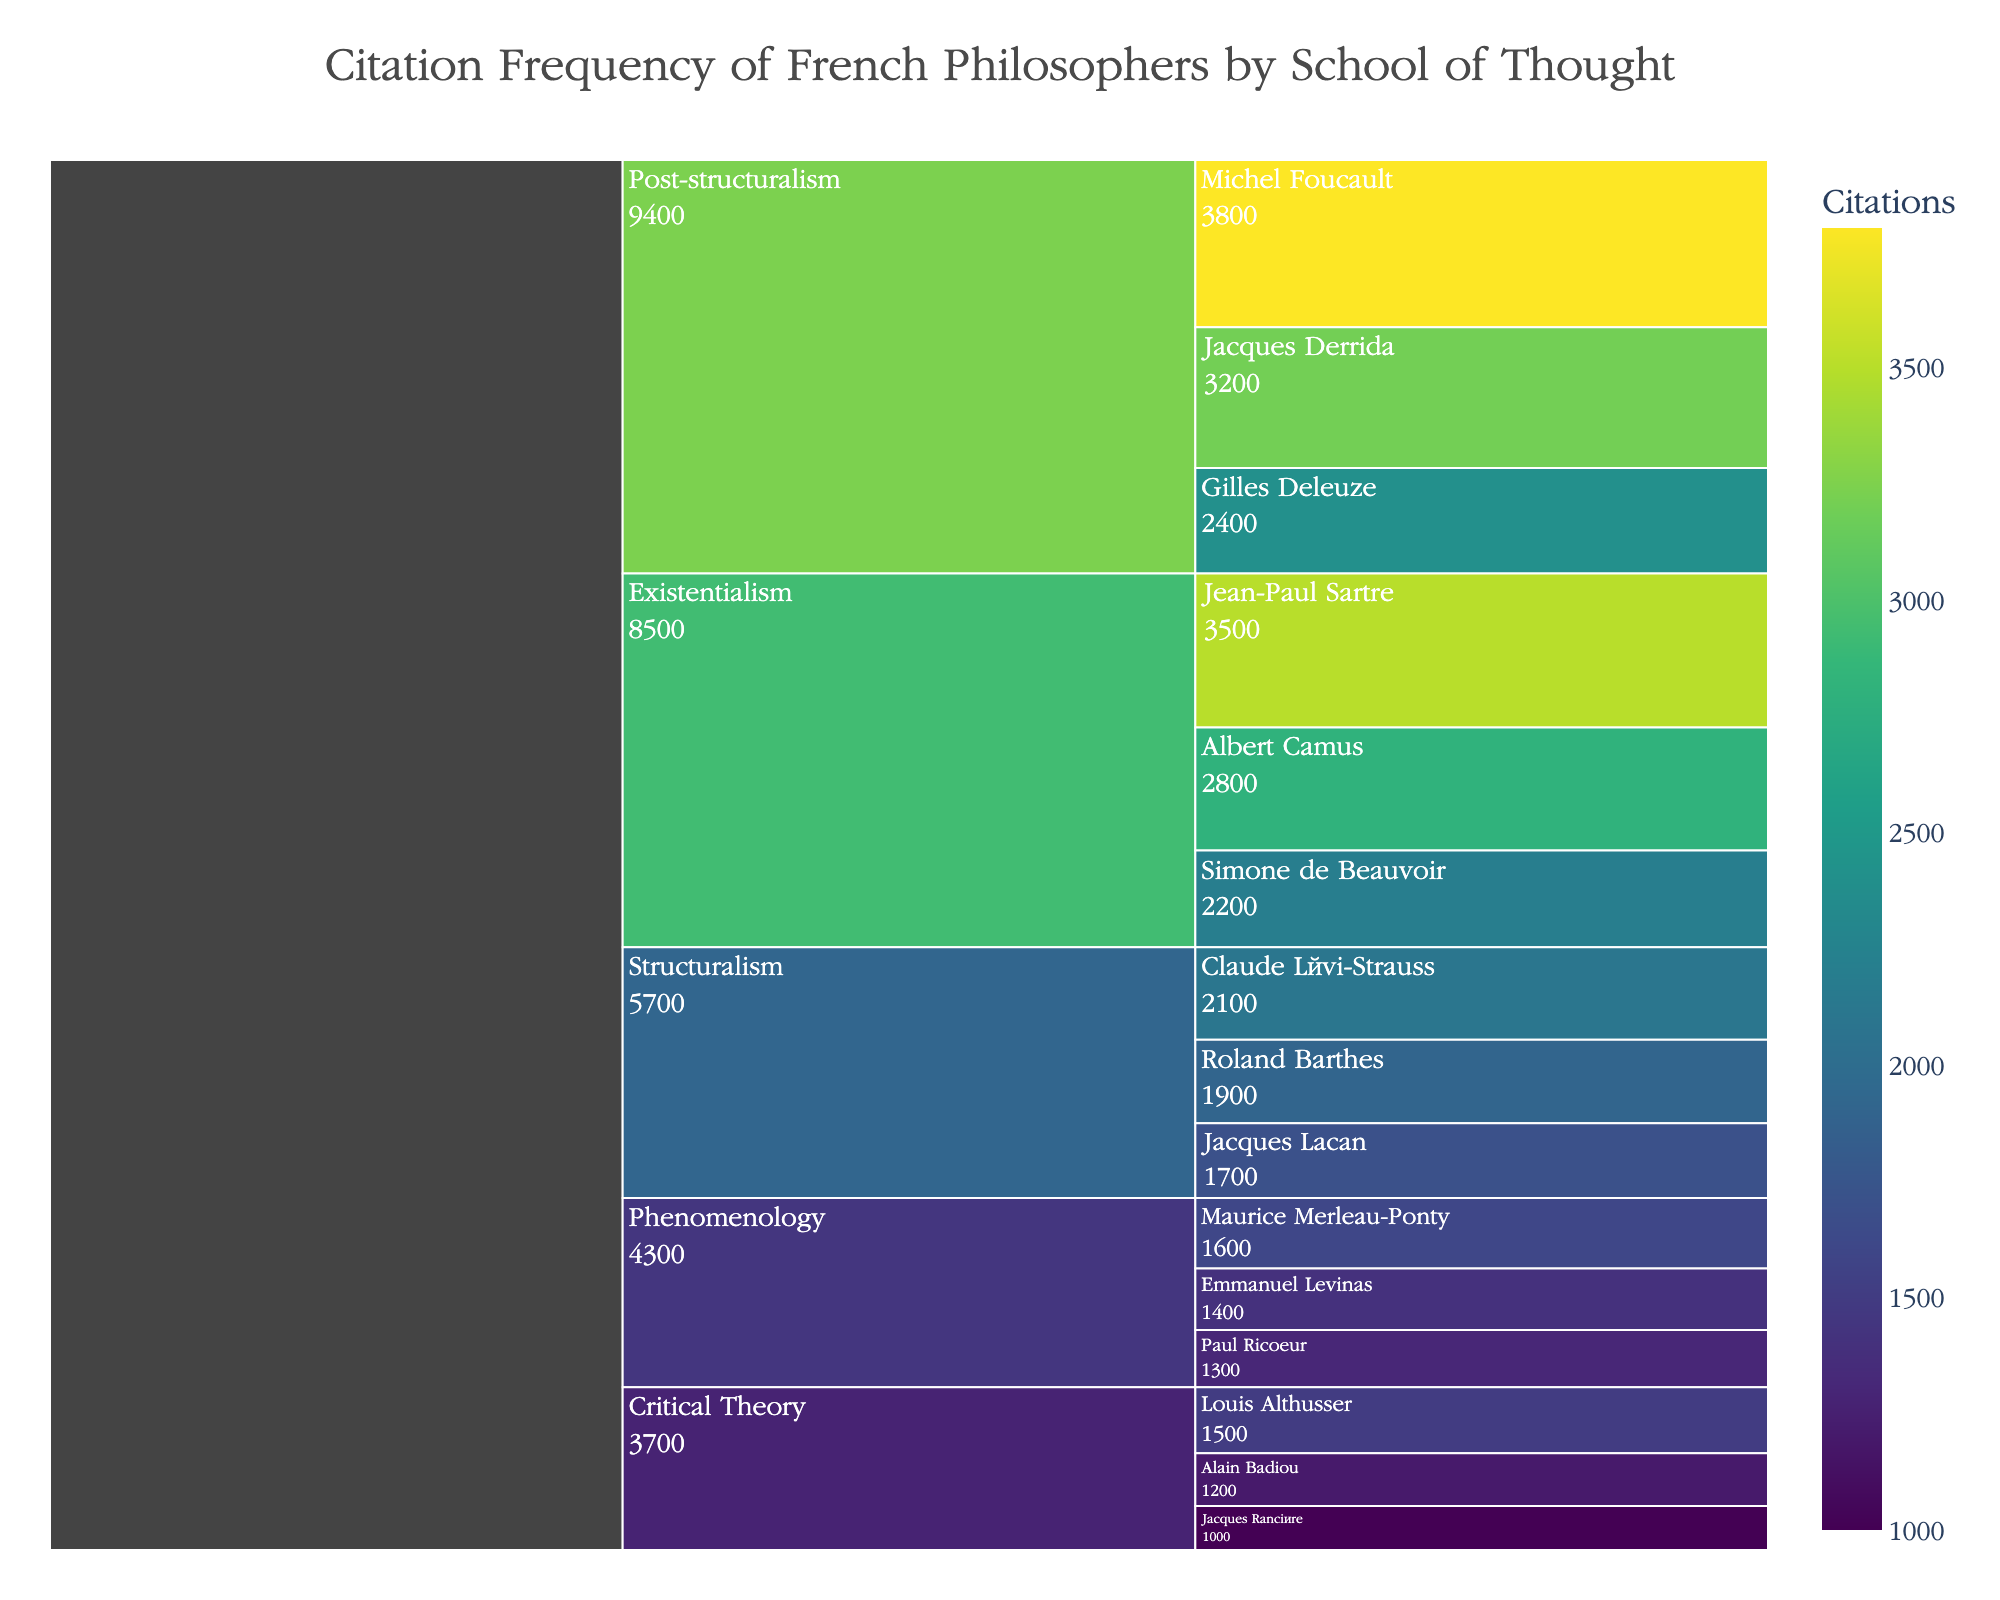what's the title of the chart? The title of the chart is usually displayed at the top center, indicating the context of the data represented. In this case, the title clearly mentions the subject.
Answer: Citation Frequency of French Philosophers by School of Thought which philosopher has the highest number of citations? Look for the section with the largest number within the chart. This would be indicated visually and by the numeric citation value displayed.
Answer: Michel Foucault how many citations are there for Structuralism philosophers in total? Sum the citation counts of Claude Lévi-Strauss, Roland Barthes, and Jacques Lacan. Their citation counts are 2100, 1900, and 1700 respectively. Calculation: 2100 + 1900 + 1700 = 5700
Answer: 5700 compare the citations of Jean-Paul Sartre and Albert Camus. Who has more? Check the values next to each philosopher's name. Jean-Paul Sartre has 3500 citations and Albert Camus has 2800 citations. Sartre has more.
Answer: Jean-Paul Sartre what is the total number of citations for philosophers in the Existentialism school of thought? Sum the numbers for Jean-Paul Sartre, Albert Camus, and Simone de Beauvoir. Their citation counts are 3500, 2800, and 2200 respectively. Calculation: 3500 + 2800 + 2200 = 8500
Answer: 8500 which school of thought has Maurice Merleau-Ponty and what is his citation count? Maurice Merleau-Ponty is part of the Phenomenology school. Look for his name within this division and note the citation count displayed next to it.
Answer: Phenomenology, 1600 what is the difference in citations between Post-structuralism and Critical Theory? Sum the citations for Post-structuralism: Jacques Derrida (3200), Michel Foucault (3800), Gilles Deleuze (2400). Sum the citations for Critical Theory: Louis Althusser (1500), Alain Badiou (1200), Jacques Rancière (1000). Calculation: 3200 + 3800 + 2400 = 9400 for Post-structuralism, and 1500 + 1200 + 1000 = 3700 for Critical Theory. Difference: 9400 - 3700 = 5700
Answer: 5700 what's the average number of citations for philosophers in Phenomenology? Calculate the sum of citations for all philosophers in Phenomenology: Maurice Merleau-Ponty (1600), Emmanuel Levinas (1400), Paul Ricoeur (1300). Sum: 1600 + 1400 + 1300 = 4300. There are 3 philosophers, so divide the total citations by 3. Calculation: 4300 / 3 ≈ 1433.33
Answer: 1433.33 